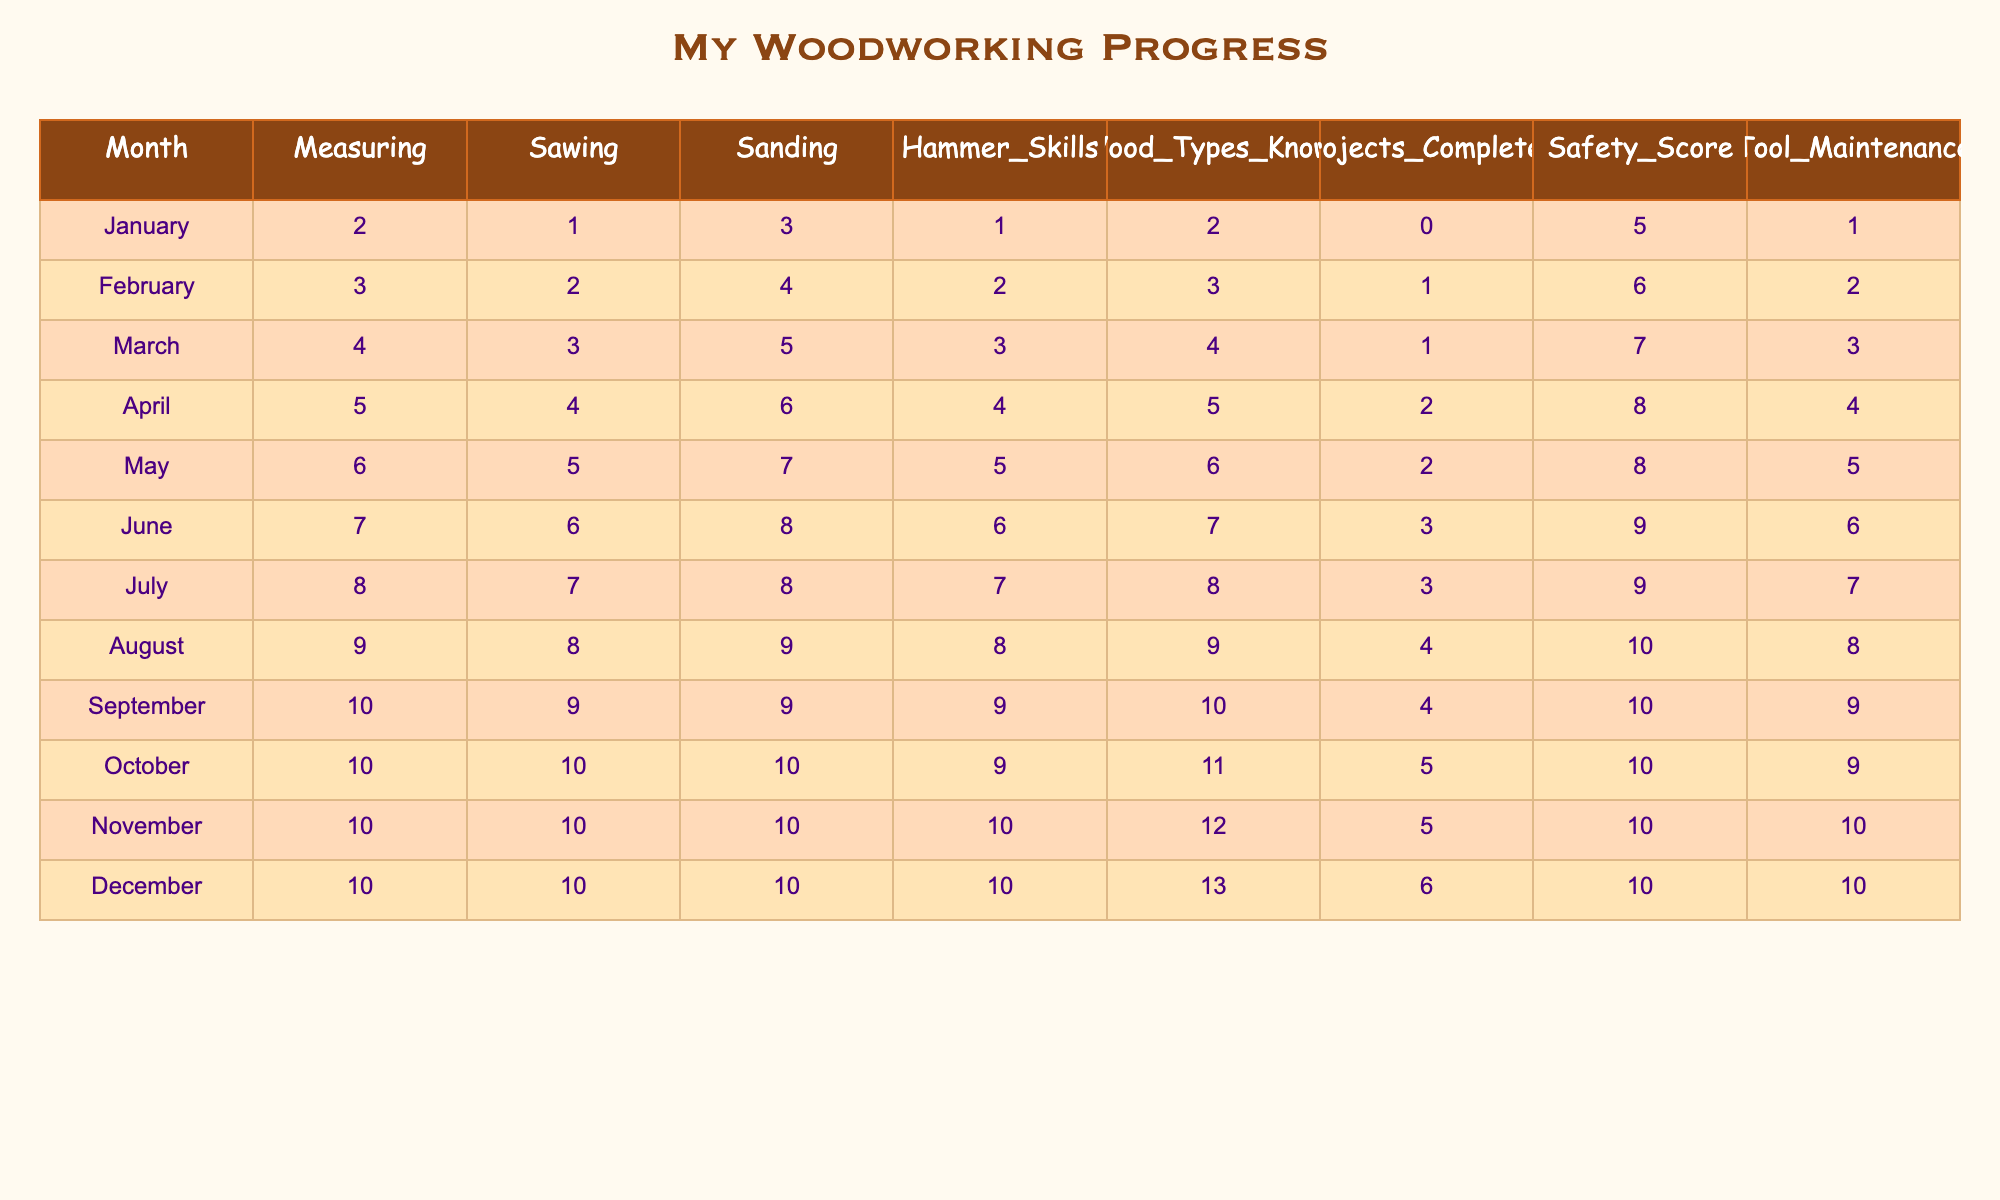What was the highest score in Safety Score? The highest Safety Score listed in the table is 10, found in the months of October, November, and December.
Answer: 10 In which month did the child complete the most projects? The maximum number of projects completed is 6, achieved in December.
Answer: December What is the average number of wood types known over the months? To find the average, add all the values of Wood Types Known (2 + 3 + 4 + 5 + 6 + 7 + 8 + 9 + 10 + 11 + 12 + 13 = 76) and divide by 12 (months) which equals 6.33.
Answer: 6.33 Is the child’s Hammer Skills score higher in December than in January? The Hammer Skills score in December is 10 and in January is 1. Since 10 is greater than 1, the statement is true.
Answer: Yes What was the change in the number of completed projects from January to June? In January, 0 projects were completed, and by June, 3 projects were completed. The change is 3 - 0 = 3.
Answer: 3 How many more wood types did the child know in August compared to March? In March, the child knew 4 wood types, while in August, they knew 9. The difference is 9 - 4 = 5.
Answer: 5 Did the child’s Sawing skill improve every month? When examining the Sawing skill scores month by month, they increase consistently from 1 in January to 10 in October, remaining unchanged for November and December, indicating a consistent improvement.
Answer: Yes What was the total sum of Safety Scores from January to December? To find the total Safety Score, add all the monthly scores: (5 + 6 + 7 + 8 + 8 + 9 + 9 + 10 + 10 + 10 + 10 + 10 = 115).
Answer: 115 In which month did the child have their least tool maintenance score? The lowest Tool Maintenance score was 1, observed in January.
Answer: January What is the difference between the maximum and minimum scores of Measuring skills throughout the year? The Measuring skill has a minimum of 2 in January and a maximum of 10 from September to December. The difference is 10 - 2 = 8.
Answer: 8 What was the total number of skills (sanding, sawing, measuring, and hammering) the child improved in September compared to January? In September, the scores were Measuring 10, Sawing 9, Sanding 9, and Hammering 9, totaling 10 + 9 + 9 + 9 = 37. In January the scores were Measuring 2, Sawing 1, Sanding 3, and Hammering 1, totaling 2 + 1 + 3 + 1 = 7. The difference is 37 - 7 = 30.
Answer: 30 